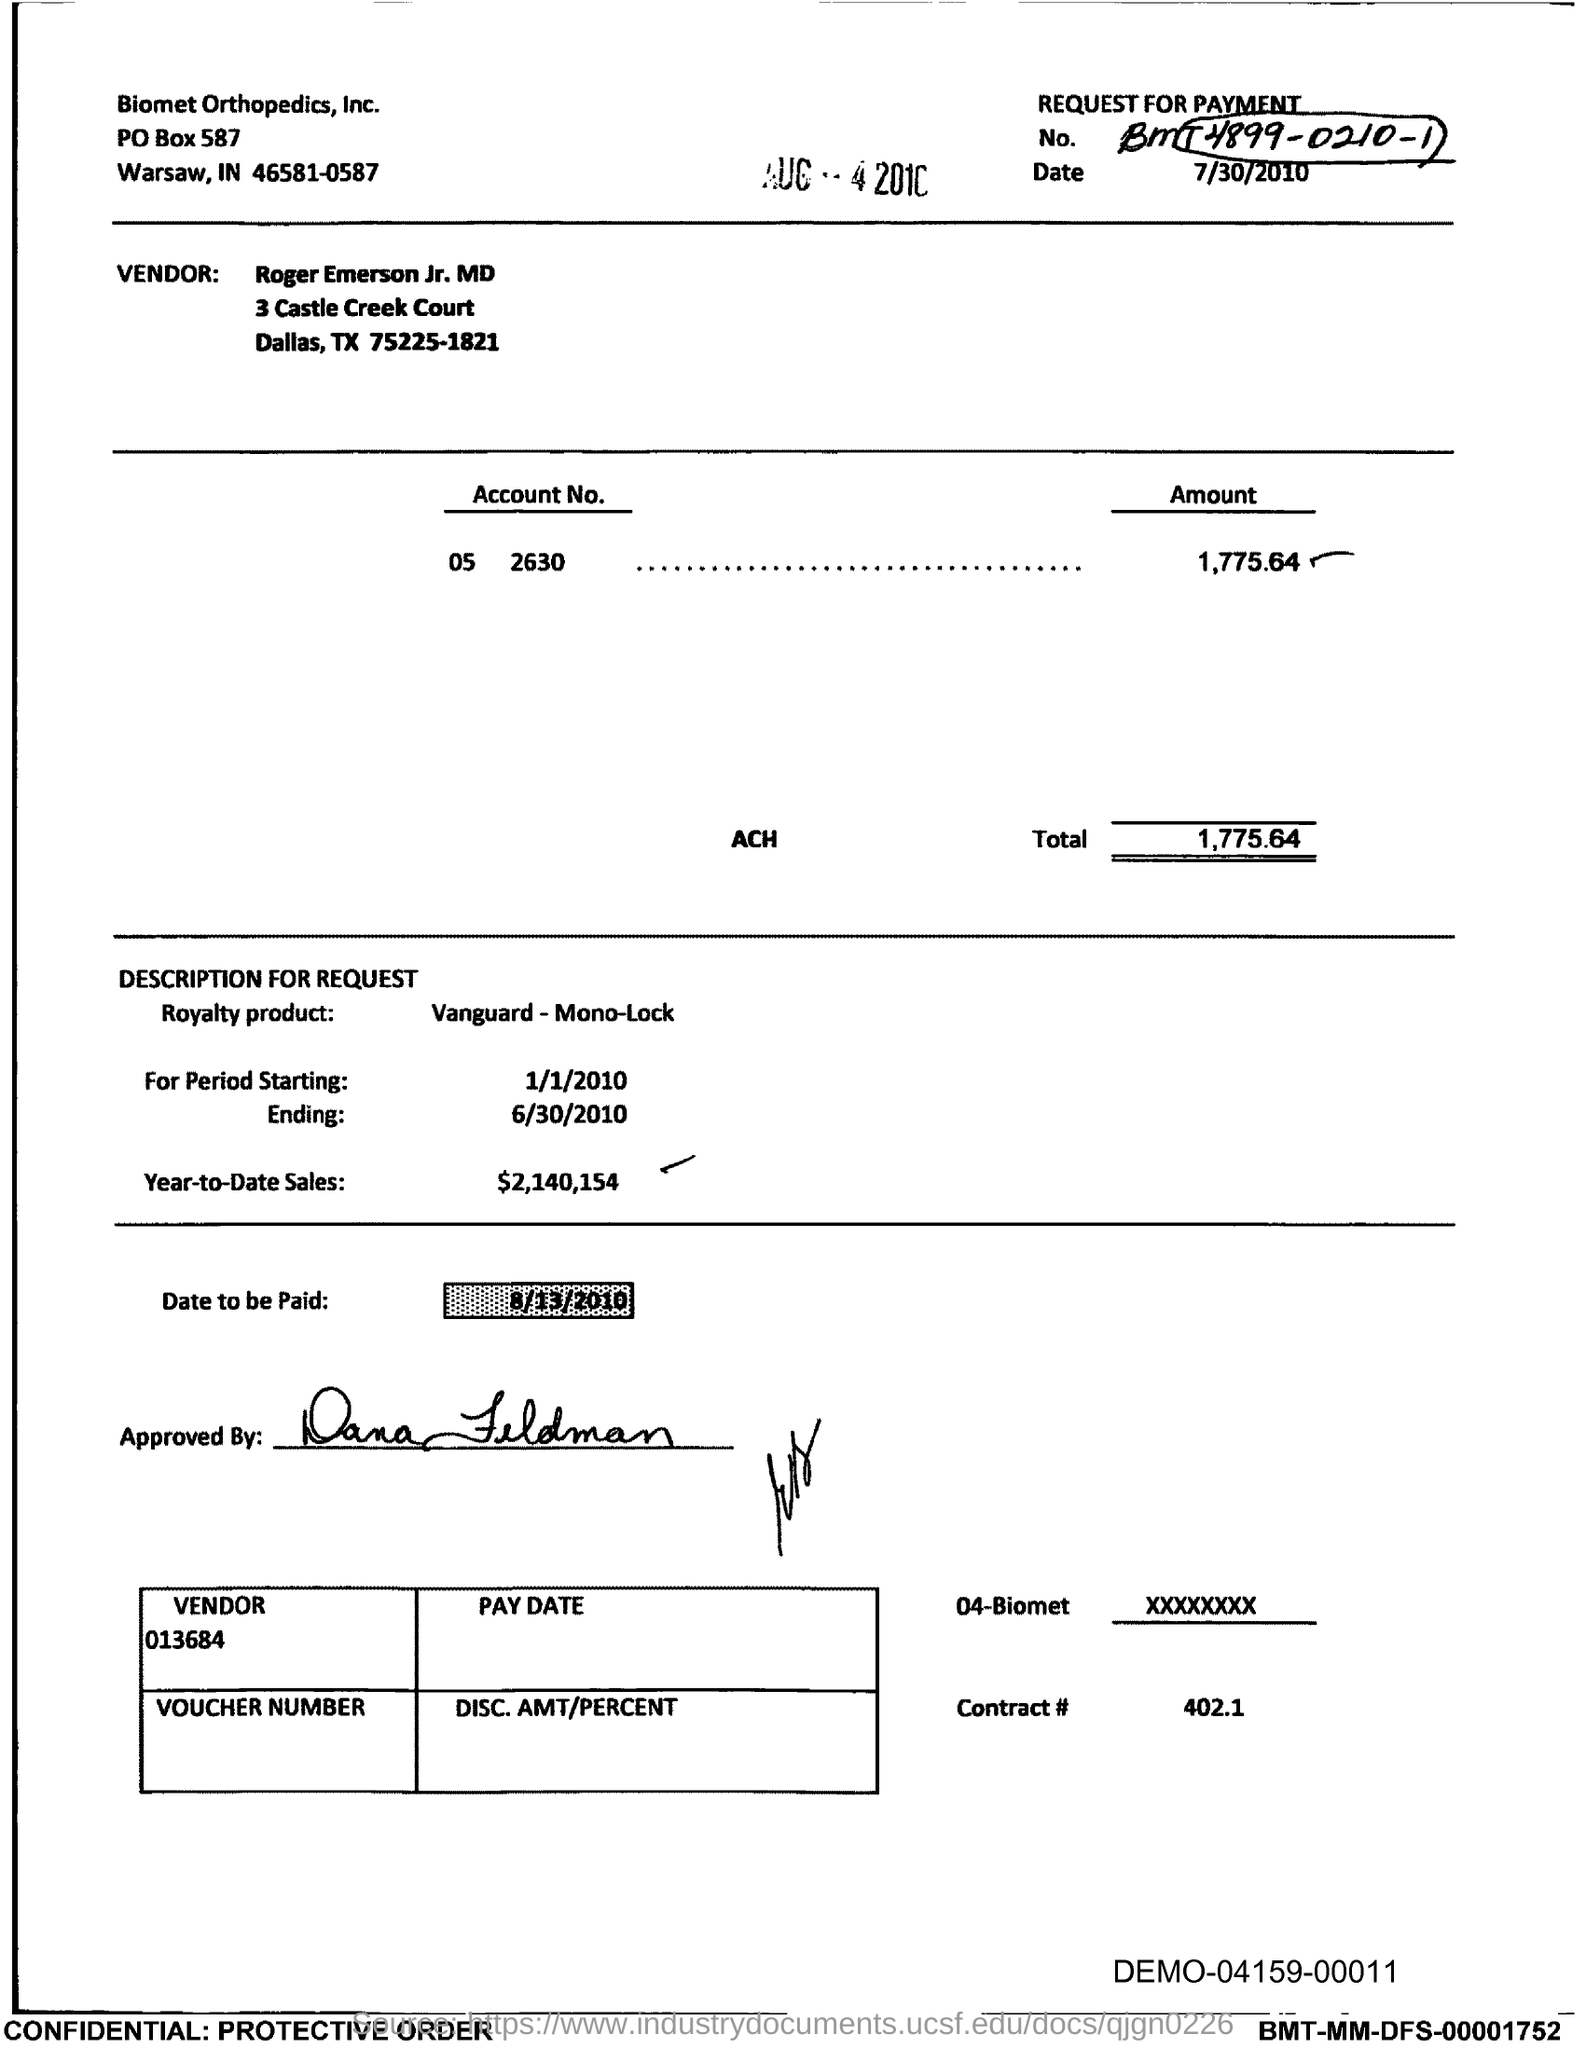Indicate a few pertinent items in this graphic. The date upon which payment is to be made, as specified in the document, is August 13, 2010. The year-to-date sales mentioned in the document are $2,140,154. The total is 1,775.64. 